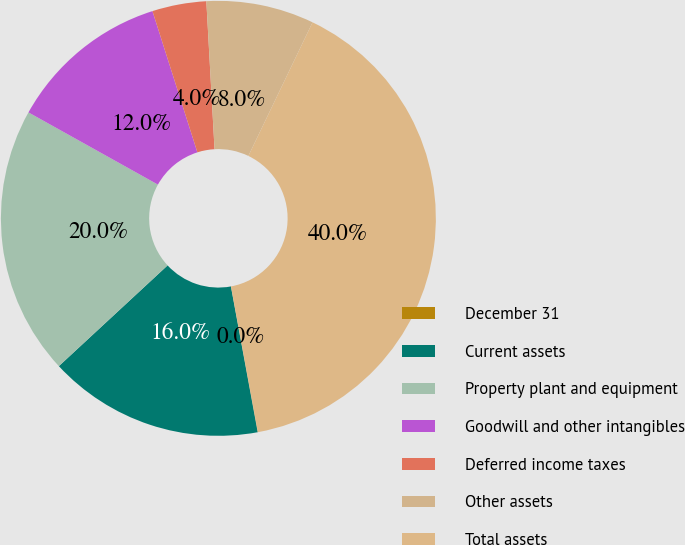Convert chart. <chart><loc_0><loc_0><loc_500><loc_500><pie_chart><fcel>December 31<fcel>Current assets<fcel>Property plant and equipment<fcel>Goodwill and other intangibles<fcel>Deferred income taxes<fcel>Other assets<fcel>Total assets<nl><fcel>0.02%<fcel>16.0%<fcel>19.99%<fcel>12.0%<fcel>4.02%<fcel>8.01%<fcel>39.96%<nl></chart> 